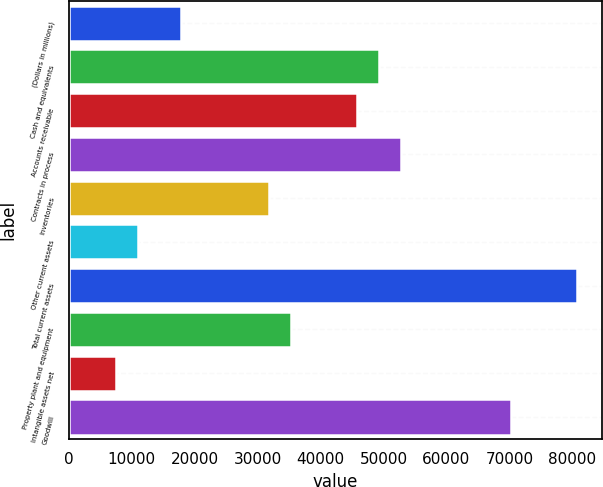Convert chart to OTSL. <chart><loc_0><loc_0><loc_500><loc_500><bar_chart><fcel>(Dollars in millions)<fcel>Cash and equivalents<fcel>Accounts receivable<fcel>Contracts in process<fcel>Inventories<fcel>Other current assets<fcel>Total current assets<fcel>Property plant and equipment<fcel>Intangible assets net<fcel>Goodwill<nl><fcel>17918.5<fcel>49304.2<fcel>45816.9<fcel>52791.5<fcel>31867.7<fcel>10943.9<fcel>80689.9<fcel>35355<fcel>7456.6<fcel>70228<nl></chart> 